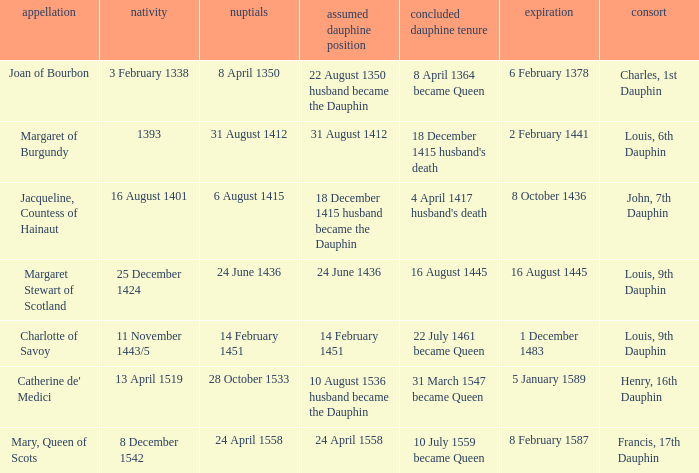When was the death when the birth was 8 december 1542? 8 February 1587. 